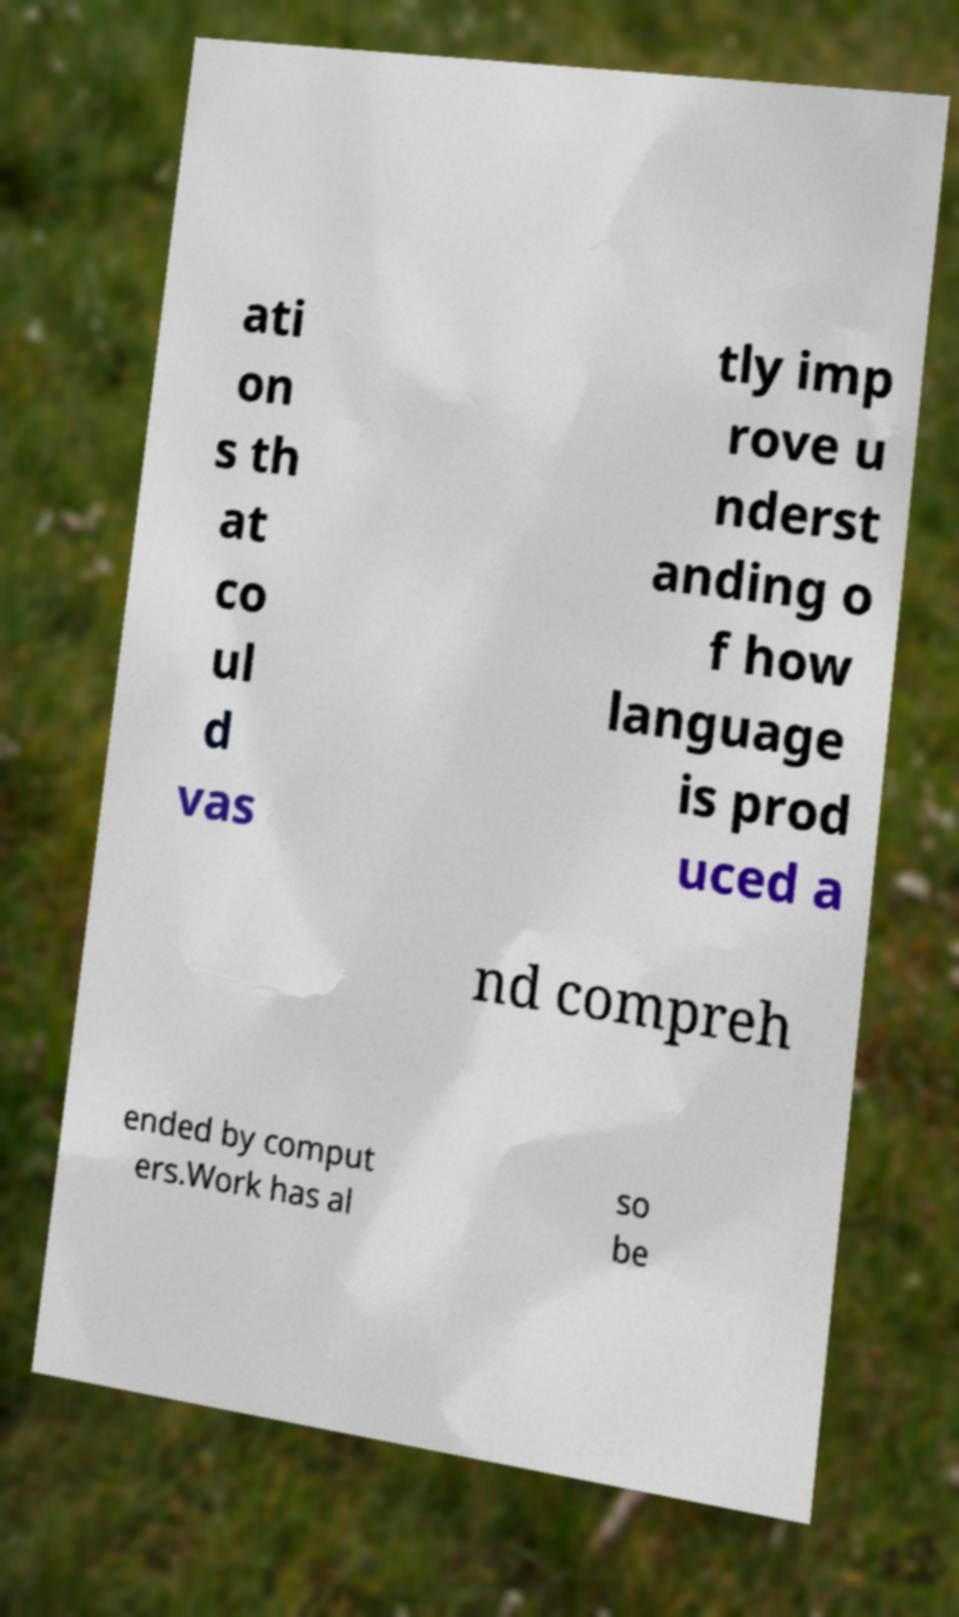Could you assist in decoding the text presented in this image and type it out clearly? ati on s th at co ul d vas tly imp rove u nderst anding o f how language is prod uced a nd compreh ended by comput ers.Work has al so be 